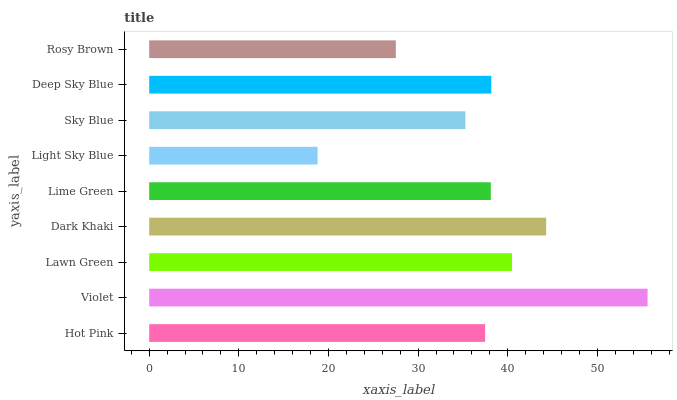Is Light Sky Blue the minimum?
Answer yes or no. Yes. Is Violet the maximum?
Answer yes or no. Yes. Is Lawn Green the minimum?
Answer yes or no. No. Is Lawn Green the maximum?
Answer yes or no. No. Is Violet greater than Lawn Green?
Answer yes or no. Yes. Is Lawn Green less than Violet?
Answer yes or no. Yes. Is Lawn Green greater than Violet?
Answer yes or no. No. Is Violet less than Lawn Green?
Answer yes or no. No. Is Lime Green the high median?
Answer yes or no. Yes. Is Lime Green the low median?
Answer yes or no. Yes. Is Light Sky Blue the high median?
Answer yes or no. No. Is Light Sky Blue the low median?
Answer yes or no. No. 